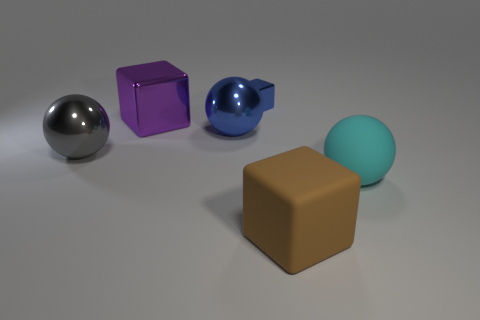What material is the large block in front of the large sphere that is in front of the big gray ball?
Give a very brief answer. Rubber. There is a blue thing that is the same shape as the big cyan rubber thing; what is it made of?
Ensure brevity in your answer.  Metal. Are any big rubber things visible?
Your answer should be compact. Yes. What is the shape of the other gray object that is the same material as the small object?
Provide a short and direct response. Sphere. There is a big cube that is behind the big gray shiny object; what material is it?
Provide a short and direct response. Metal. There is a shiny object that is on the right side of the large blue thing; is it the same color as the matte ball?
Your response must be concise. No. There is a blue metal object on the left side of the shiny cube on the right side of the purple shiny cube; what is its size?
Provide a succinct answer. Large. Is the number of small things that are on the right side of the big purple cube greater than the number of big green metallic balls?
Your response must be concise. Yes. Do the block in front of the cyan thing and the large gray metal thing have the same size?
Offer a very short reply. Yes. There is a sphere that is to the right of the big gray ball and to the left of the brown object; what color is it?
Give a very brief answer. Blue. 